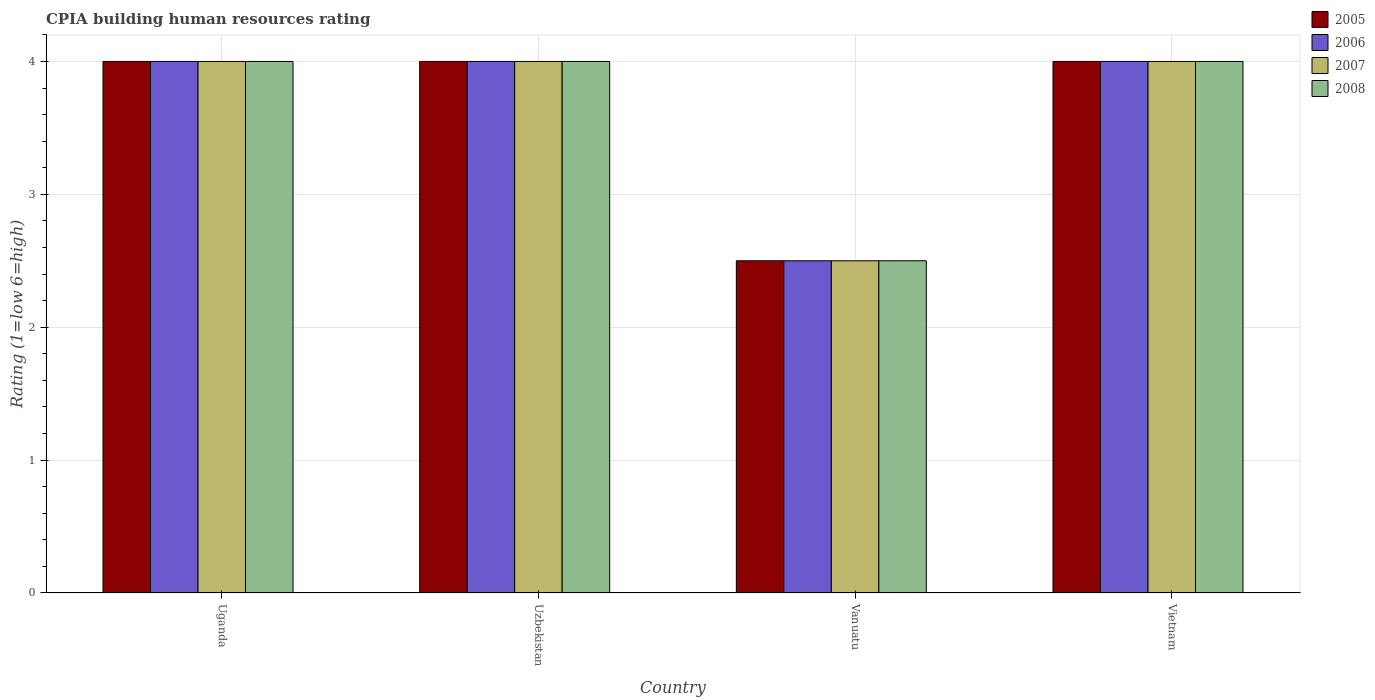How many different coloured bars are there?
Offer a terse response. 4. How many groups of bars are there?
Provide a short and direct response. 4. Are the number of bars per tick equal to the number of legend labels?
Give a very brief answer. Yes. How many bars are there on the 2nd tick from the left?
Your response must be concise. 4. How many bars are there on the 4th tick from the right?
Ensure brevity in your answer.  4. What is the label of the 2nd group of bars from the left?
Ensure brevity in your answer.  Uzbekistan. In how many cases, is the number of bars for a given country not equal to the number of legend labels?
Your answer should be compact. 0. What is the CPIA rating in 2008 in Vietnam?
Ensure brevity in your answer.  4. Across all countries, what is the maximum CPIA rating in 2007?
Provide a short and direct response. 4. In which country was the CPIA rating in 2008 maximum?
Offer a terse response. Uganda. In which country was the CPIA rating in 2008 minimum?
Provide a short and direct response. Vanuatu. What is the difference between the CPIA rating in 2006 in Vanuatu and the CPIA rating in 2008 in Vietnam?
Offer a very short reply. -1.5. What is the average CPIA rating in 2006 per country?
Your response must be concise. 3.62. What is the ratio of the CPIA rating in 2006 in Uganda to that in Vietnam?
Your answer should be very brief. 1. Is the CPIA rating in 2006 in Uganda less than that in Vanuatu?
Make the answer very short. No. Is the sum of the CPIA rating in 2007 in Uganda and Vietnam greater than the maximum CPIA rating in 2006 across all countries?
Provide a succinct answer. Yes. Is it the case that in every country, the sum of the CPIA rating in 2008 and CPIA rating in 2005 is greater than the sum of CPIA rating in 2006 and CPIA rating in 2007?
Your answer should be compact. No. What does the 1st bar from the left in Vanuatu represents?
Give a very brief answer. 2005. What is the difference between two consecutive major ticks on the Y-axis?
Make the answer very short. 1. Are the values on the major ticks of Y-axis written in scientific E-notation?
Give a very brief answer. No. Does the graph contain any zero values?
Offer a very short reply. No. Does the graph contain grids?
Offer a terse response. Yes. How many legend labels are there?
Offer a very short reply. 4. What is the title of the graph?
Offer a terse response. CPIA building human resources rating. Does "2006" appear as one of the legend labels in the graph?
Keep it short and to the point. Yes. What is the label or title of the X-axis?
Your answer should be very brief. Country. What is the Rating (1=low 6=high) of 2006 in Uganda?
Make the answer very short. 4. What is the Rating (1=low 6=high) in 2005 in Uzbekistan?
Provide a succinct answer. 4. What is the Rating (1=low 6=high) of 2006 in Uzbekistan?
Keep it short and to the point. 4. What is the Rating (1=low 6=high) of 2008 in Uzbekistan?
Give a very brief answer. 4. What is the Rating (1=low 6=high) in 2006 in Vanuatu?
Provide a short and direct response. 2.5. What is the Rating (1=low 6=high) of 2008 in Vanuatu?
Your answer should be compact. 2.5. What is the Rating (1=low 6=high) in 2005 in Vietnam?
Your answer should be very brief. 4. What is the Rating (1=low 6=high) of 2008 in Vietnam?
Your answer should be compact. 4. Across all countries, what is the maximum Rating (1=low 6=high) of 2005?
Your response must be concise. 4. Across all countries, what is the maximum Rating (1=low 6=high) in 2007?
Your answer should be compact. 4. Across all countries, what is the minimum Rating (1=low 6=high) in 2006?
Give a very brief answer. 2.5. Across all countries, what is the minimum Rating (1=low 6=high) of 2007?
Make the answer very short. 2.5. Across all countries, what is the minimum Rating (1=low 6=high) in 2008?
Ensure brevity in your answer.  2.5. What is the total Rating (1=low 6=high) of 2005 in the graph?
Give a very brief answer. 14.5. What is the difference between the Rating (1=low 6=high) of 2005 in Uganda and that in Uzbekistan?
Keep it short and to the point. 0. What is the difference between the Rating (1=low 6=high) in 2007 in Uganda and that in Uzbekistan?
Your answer should be compact. 0. What is the difference between the Rating (1=low 6=high) in 2005 in Uganda and that in Vanuatu?
Your answer should be very brief. 1.5. What is the difference between the Rating (1=low 6=high) in 2006 in Uganda and that in Vanuatu?
Give a very brief answer. 1.5. What is the difference between the Rating (1=low 6=high) of 2008 in Uganda and that in Vanuatu?
Provide a short and direct response. 1.5. What is the difference between the Rating (1=low 6=high) in 2006 in Uganda and that in Vietnam?
Ensure brevity in your answer.  0. What is the difference between the Rating (1=low 6=high) in 2007 in Uganda and that in Vietnam?
Your answer should be compact. 0. What is the difference between the Rating (1=low 6=high) of 2005 in Uzbekistan and that in Vanuatu?
Give a very brief answer. 1.5. What is the difference between the Rating (1=low 6=high) of 2008 in Uzbekistan and that in Vanuatu?
Offer a terse response. 1.5. What is the difference between the Rating (1=low 6=high) of 2005 in Uzbekistan and that in Vietnam?
Provide a short and direct response. 0. What is the difference between the Rating (1=low 6=high) of 2005 in Vanuatu and that in Vietnam?
Provide a short and direct response. -1.5. What is the difference between the Rating (1=low 6=high) in 2007 in Vanuatu and that in Vietnam?
Your response must be concise. -1.5. What is the difference between the Rating (1=low 6=high) in 2008 in Vanuatu and that in Vietnam?
Give a very brief answer. -1.5. What is the difference between the Rating (1=low 6=high) of 2005 in Uganda and the Rating (1=low 6=high) of 2007 in Uzbekistan?
Keep it short and to the point. 0. What is the difference between the Rating (1=low 6=high) in 2005 in Uganda and the Rating (1=low 6=high) in 2008 in Uzbekistan?
Give a very brief answer. 0. What is the difference between the Rating (1=low 6=high) in 2007 in Uganda and the Rating (1=low 6=high) in 2008 in Uzbekistan?
Give a very brief answer. 0. What is the difference between the Rating (1=low 6=high) of 2005 in Uganda and the Rating (1=low 6=high) of 2006 in Vanuatu?
Your response must be concise. 1.5. What is the difference between the Rating (1=low 6=high) in 2005 in Uganda and the Rating (1=low 6=high) in 2007 in Vanuatu?
Your response must be concise. 1.5. What is the difference between the Rating (1=low 6=high) of 2005 in Uganda and the Rating (1=low 6=high) of 2008 in Vanuatu?
Provide a short and direct response. 1.5. What is the difference between the Rating (1=low 6=high) in 2006 in Uganda and the Rating (1=low 6=high) in 2007 in Vanuatu?
Provide a succinct answer. 1.5. What is the difference between the Rating (1=low 6=high) of 2005 in Uganda and the Rating (1=low 6=high) of 2007 in Vietnam?
Make the answer very short. 0. What is the difference between the Rating (1=low 6=high) in 2005 in Uganda and the Rating (1=low 6=high) in 2008 in Vietnam?
Make the answer very short. 0. What is the difference between the Rating (1=low 6=high) of 2005 in Uzbekistan and the Rating (1=low 6=high) of 2007 in Vanuatu?
Provide a succinct answer. 1.5. What is the difference between the Rating (1=low 6=high) of 2006 in Uzbekistan and the Rating (1=low 6=high) of 2008 in Vanuatu?
Offer a terse response. 1.5. What is the difference between the Rating (1=low 6=high) of 2007 in Uzbekistan and the Rating (1=low 6=high) of 2008 in Vanuatu?
Keep it short and to the point. 1.5. What is the difference between the Rating (1=low 6=high) of 2005 in Uzbekistan and the Rating (1=low 6=high) of 2008 in Vietnam?
Ensure brevity in your answer.  0. What is the difference between the Rating (1=low 6=high) of 2007 in Uzbekistan and the Rating (1=low 6=high) of 2008 in Vietnam?
Ensure brevity in your answer.  0. What is the difference between the Rating (1=low 6=high) in 2005 in Vanuatu and the Rating (1=low 6=high) in 2007 in Vietnam?
Offer a terse response. -1.5. What is the difference between the Rating (1=low 6=high) of 2006 in Vanuatu and the Rating (1=low 6=high) of 2007 in Vietnam?
Give a very brief answer. -1.5. What is the difference between the Rating (1=low 6=high) in 2006 in Vanuatu and the Rating (1=low 6=high) in 2008 in Vietnam?
Offer a very short reply. -1.5. What is the difference between the Rating (1=low 6=high) in 2007 in Vanuatu and the Rating (1=low 6=high) in 2008 in Vietnam?
Offer a very short reply. -1.5. What is the average Rating (1=low 6=high) in 2005 per country?
Offer a very short reply. 3.62. What is the average Rating (1=low 6=high) in 2006 per country?
Ensure brevity in your answer.  3.62. What is the average Rating (1=low 6=high) of 2007 per country?
Provide a succinct answer. 3.62. What is the average Rating (1=low 6=high) in 2008 per country?
Make the answer very short. 3.62. What is the difference between the Rating (1=low 6=high) in 2005 and Rating (1=low 6=high) in 2006 in Uganda?
Offer a terse response. 0. What is the difference between the Rating (1=low 6=high) of 2005 and Rating (1=low 6=high) of 2007 in Uganda?
Keep it short and to the point. 0. What is the difference between the Rating (1=low 6=high) of 2005 and Rating (1=low 6=high) of 2008 in Uganda?
Make the answer very short. 0. What is the difference between the Rating (1=low 6=high) of 2006 and Rating (1=low 6=high) of 2007 in Uganda?
Make the answer very short. 0. What is the difference between the Rating (1=low 6=high) in 2006 and Rating (1=low 6=high) in 2008 in Uganda?
Ensure brevity in your answer.  0. What is the difference between the Rating (1=low 6=high) of 2007 and Rating (1=low 6=high) of 2008 in Uganda?
Offer a terse response. 0. What is the difference between the Rating (1=low 6=high) in 2005 and Rating (1=low 6=high) in 2006 in Uzbekistan?
Provide a succinct answer. 0. What is the difference between the Rating (1=low 6=high) of 2005 and Rating (1=low 6=high) of 2007 in Uzbekistan?
Your answer should be compact. 0. What is the difference between the Rating (1=low 6=high) in 2005 and Rating (1=low 6=high) in 2008 in Uzbekistan?
Provide a succinct answer. 0. What is the difference between the Rating (1=low 6=high) in 2006 and Rating (1=low 6=high) in 2007 in Uzbekistan?
Your answer should be compact. 0. What is the difference between the Rating (1=low 6=high) of 2006 and Rating (1=low 6=high) of 2008 in Vanuatu?
Keep it short and to the point. 0. What is the difference between the Rating (1=low 6=high) of 2005 and Rating (1=low 6=high) of 2007 in Vietnam?
Your answer should be very brief. 0. What is the difference between the Rating (1=low 6=high) of 2005 and Rating (1=low 6=high) of 2008 in Vietnam?
Give a very brief answer. 0. What is the difference between the Rating (1=low 6=high) of 2006 and Rating (1=low 6=high) of 2007 in Vietnam?
Make the answer very short. 0. What is the difference between the Rating (1=low 6=high) in 2007 and Rating (1=low 6=high) in 2008 in Vietnam?
Your answer should be very brief. 0. What is the ratio of the Rating (1=low 6=high) of 2005 in Uganda to that in Uzbekistan?
Make the answer very short. 1. What is the ratio of the Rating (1=low 6=high) of 2006 in Uganda to that in Uzbekistan?
Your response must be concise. 1. What is the ratio of the Rating (1=low 6=high) in 2007 in Uganda to that in Uzbekistan?
Provide a succinct answer. 1. What is the ratio of the Rating (1=low 6=high) in 2005 in Uganda to that in Vanuatu?
Your answer should be compact. 1.6. What is the ratio of the Rating (1=low 6=high) of 2006 in Uganda to that in Vanuatu?
Ensure brevity in your answer.  1.6. What is the ratio of the Rating (1=low 6=high) of 2007 in Uganda to that in Vanuatu?
Give a very brief answer. 1.6. What is the ratio of the Rating (1=low 6=high) in 2008 in Uganda to that in Vanuatu?
Offer a terse response. 1.6. What is the ratio of the Rating (1=low 6=high) of 2006 in Uganda to that in Vietnam?
Your answer should be very brief. 1. What is the ratio of the Rating (1=low 6=high) in 2008 in Uganda to that in Vietnam?
Your answer should be very brief. 1. What is the ratio of the Rating (1=low 6=high) of 2005 in Uzbekistan to that in Vanuatu?
Provide a succinct answer. 1.6. What is the ratio of the Rating (1=low 6=high) in 2007 in Uzbekistan to that in Vanuatu?
Provide a short and direct response. 1.6. What is the ratio of the Rating (1=low 6=high) of 2006 in Uzbekistan to that in Vietnam?
Give a very brief answer. 1. What is the ratio of the Rating (1=low 6=high) in 2007 in Uzbekistan to that in Vietnam?
Your answer should be compact. 1. What is the ratio of the Rating (1=low 6=high) in 2008 in Uzbekistan to that in Vietnam?
Provide a short and direct response. 1. What is the ratio of the Rating (1=low 6=high) of 2006 in Vanuatu to that in Vietnam?
Your response must be concise. 0.62. What is the difference between the highest and the second highest Rating (1=low 6=high) in 2007?
Your answer should be compact. 0. What is the difference between the highest and the lowest Rating (1=low 6=high) of 2005?
Make the answer very short. 1.5. What is the difference between the highest and the lowest Rating (1=low 6=high) in 2006?
Make the answer very short. 1.5. What is the difference between the highest and the lowest Rating (1=low 6=high) in 2008?
Provide a short and direct response. 1.5. 